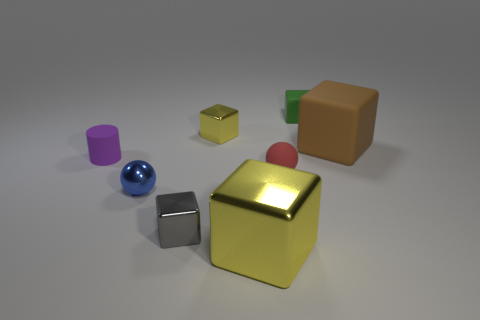Subtract all green matte cubes. How many cubes are left? 4 Subtract all gray blocks. How many blocks are left? 4 Subtract all red cubes. Subtract all cyan spheres. How many cubes are left? 5 Add 1 small green things. How many objects exist? 9 Subtract all blocks. How many objects are left? 3 Subtract all small green matte cubes. Subtract all large objects. How many objects are left? 5 Add 5 blue balls. How many blue balls are left? 6 Add 2 metal spheres. How many metal spheres exist? 3 Subtract 0 cyan blocks. How many objects are left? 8 